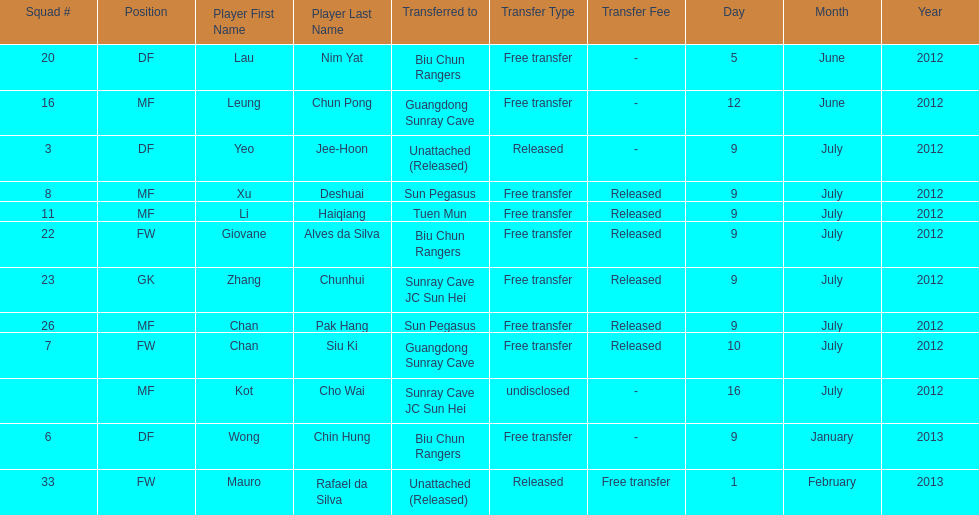Li haiqiang and xu deshuai both played which position? MF. 